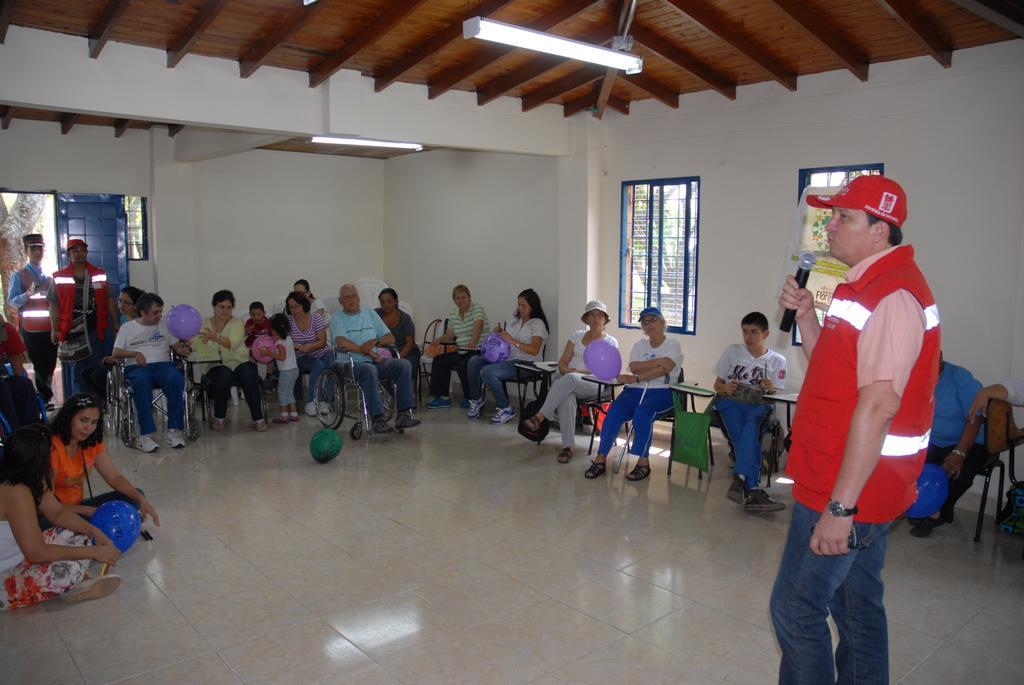How would you summarize this image in a sentence or two? In this image I can see number of people where few are sitting on chairs, few are sitting on floor and few are standing. I can also see three of them are wearing red colour jackets, caps and here I can see she is holding a mic. In the background I can see windows and few lights. 